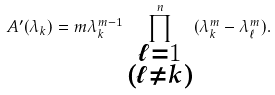Convert formula to latex. <formula><loc_0><loc_0><loc_500><loc_500>A ^ { \prime } ( \lambda _ { k } ) = m \lambda _ { k } ^ { m - 1 } \prod _ { \substack { \ell = 1 \\ ( \ell \neq k ) } } ^ { n } ( \lambda _ { k } ^ { m } - \lambda _ { \ell } ^ { m } ) .</formula> 